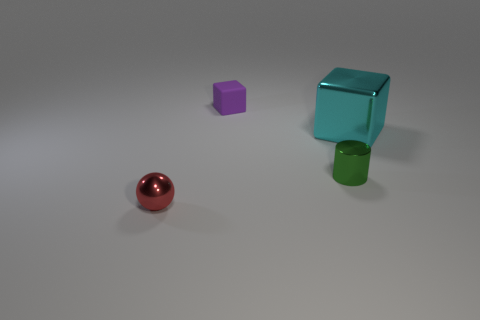There is a tiny thing behind the metallic cylinder; is its shape the same as the metallic thing that is to the right of the metal cylinder?
Make the answer very short. Yes. Is the material of the small thing behind the large cyan object the same as the object that is to the right of the small metallic cylinder?
Make the answer very short. No. What material is the tiny object that is on the left side of the block behind the big metallic block?
Offer a terse response. Metal. There is a thing in front of the tiny metal thing that is to the right of the block on the left side of the big thing; what is its shape?
Provide a succinct answer. Sphere. What is the material of the cyan object that is the same shape as the tiny purple matte object?
Provide a short and direct response. Metal. How many red matte balls are there?
Your answer should be very brief. 0. The small metal thing that is on the right side of the small matte thing has what shape?
Offer a terse response. Cylinder. What color is the small shiny thing that is to the left of the tiny metal thing that is right of the small metallic object on the left side of the rubber block?
Make the answer very short. Red. The big cyan object that is the same material as the red sphere is what shape?
Your answer should be very brief. Cube. Are there fewer red shiny objects than small yellow things?
Your answer should be very brief. No. 